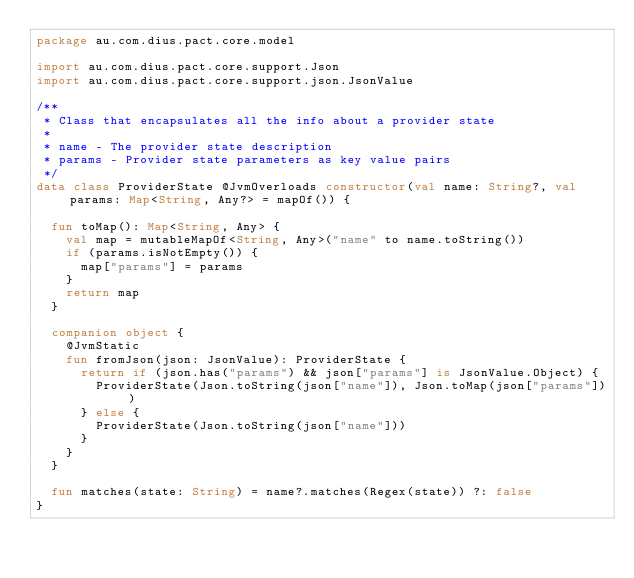Convert code to text. <code><loc_0><loc_0><loc_500><loc_500><_Kotlin_>package au.com.dius.pact.core.model

import au.com.dius.pact.core.support.Json
import au.com.dius.pact.core.support.json.JsonValue

/**
 * Class that encapsulates all the info about a provider state
 *
 * name - The provider state description
 * params - Provider state parameters as key value pairs
 */
data class ProviderState @JvmOverloads constructor(val name: String?, val params: Map<String, Any?> = mapOf()) {

  fun toMap(): Map<String, Any> {
    val map = mutableMapOf<String, Any>("name" to name.toString())
    if (params.isNotEmpty()) {
      map["params"] = params
    }
    return map
  }

  companion object {
    @JvmStatic
    fun fromJson(json: JsonValue): ProviderState {
      return if (json.has("params") && json["params"] is JsonValue.Object) {
        ProviderState(Json.toString(json["name"]), Json.toMap(json["params"]))
      } else {
        ProviderState(Json.toString(json["name"]))
      }
    }
  }

  fun matches(state: String) = name?.matches(Regex(state)) ?: false
}
</code> 